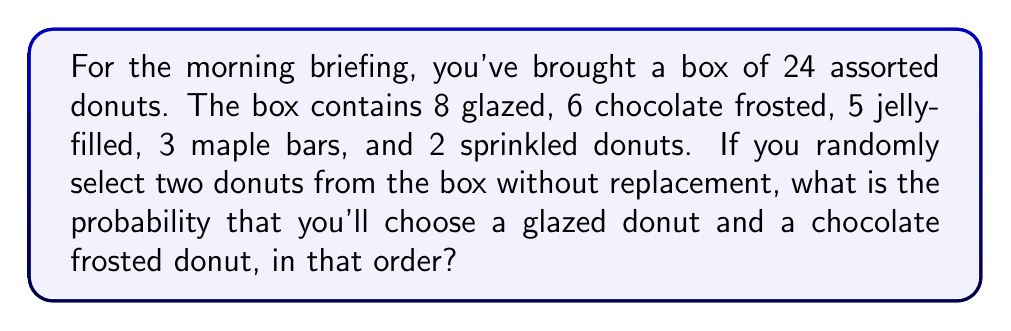Can you solve this math problem? Let's approach this step-by-step:

1) First, we need to calculate the probability of selecting a glazed donut on the first pick:

   $P(\text{glazed first}) = \frac{8}{24} = \frac{1}{3}$

2) After selecting a glazed donut, there are 23 donuts left, of which 6 are chocolate frosted. So the probability of selecting a chocolate frosted donut on the second pick is:

   $P(\text{chocolate second | glazed first}) = \frac{6}{23}$

3) The probability of both events occurring in this specific order is the product of their individual probabilities:

   $P(\text{glazed then chocolate}) = P(\text{glazed first}) \times P(\text{chocolate second | glazed first})$

   $= \frac{1}{3} \times \frac{6}{23}$

4) Let's calculate this:

   $\frac{1}{3} \times \frac{6}{23} = \frac{6}{69} = \frac{2}{23}$

Therefore, the probability of selecting a glazed donut first and then a chocolate frosted donut is $\frac{2}{23}$.
Answer: $\frac{2}{23}$ 